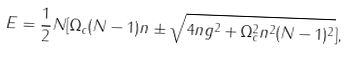Convert formula to latex. <formula><loc_0><loc_0><loc_500><loc_500>E = \frac { 1 } { 2 } N [ \Omega _ { c } ( N - 1 ) n \pm \sqrt { 4 n g ^ { 2 } + \Omega _ { c } ^ { 2 } n ^ { 2 } ( N - 1 ) ^ { 2 } } ] ,</formula> 